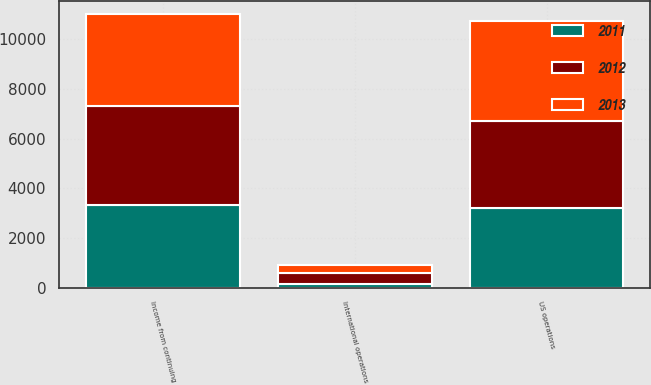<chart> <loc_0><loc_0><loc_500><loc_500><stacked_bar_chart><ecel><fcel>US operations<fcel>International operations<fcel>Income from continuing<nl><fcel>2012<fcel>3531<fcel>451<fcel>3982<nl><fcel>2013<fcel>4015<fcel>309<fcel>3706<nl><fcel>2011<fcel>3190<fcel>132<fcel>3322<nl></chart> 